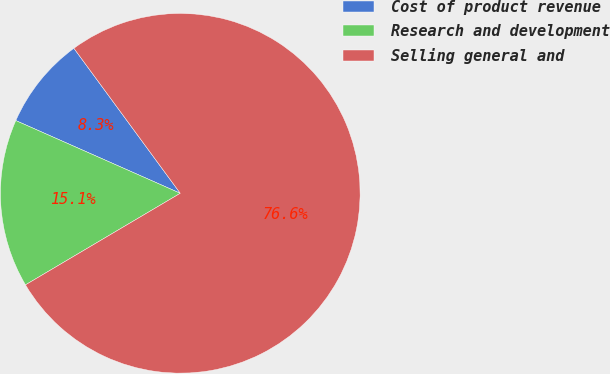Convert chart to OTSL. <chart><loc_0><loc_0><loc_500><loc_500><pie_chart><fcel>Cost of product revenue<fcel>Research and development<fcel>Selling general and<nl><fcel>8.3%<fcel>15.13%<fcel>76.57%<nl></chart> 